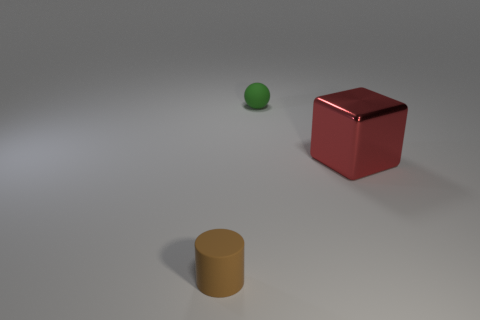Add 3 matte blocks. How many objects exist? 6 Add 2 big red metal things. How many big red metal things exist? 3 Subtract 0 blue spheres. How many objects are left? 3 Subtract all balls. How many objects are left? 2 Subtract all gray cylinders. Subtract all purple spheres. How many cylinders are left? 1 Subtract all cyan spheres. How many blue blocks are left? 0 Subtract all red cubes. Subtract all big red things. How many objects are left? 1 Add 1 tiny green things. How many tiny green things are left? 2 